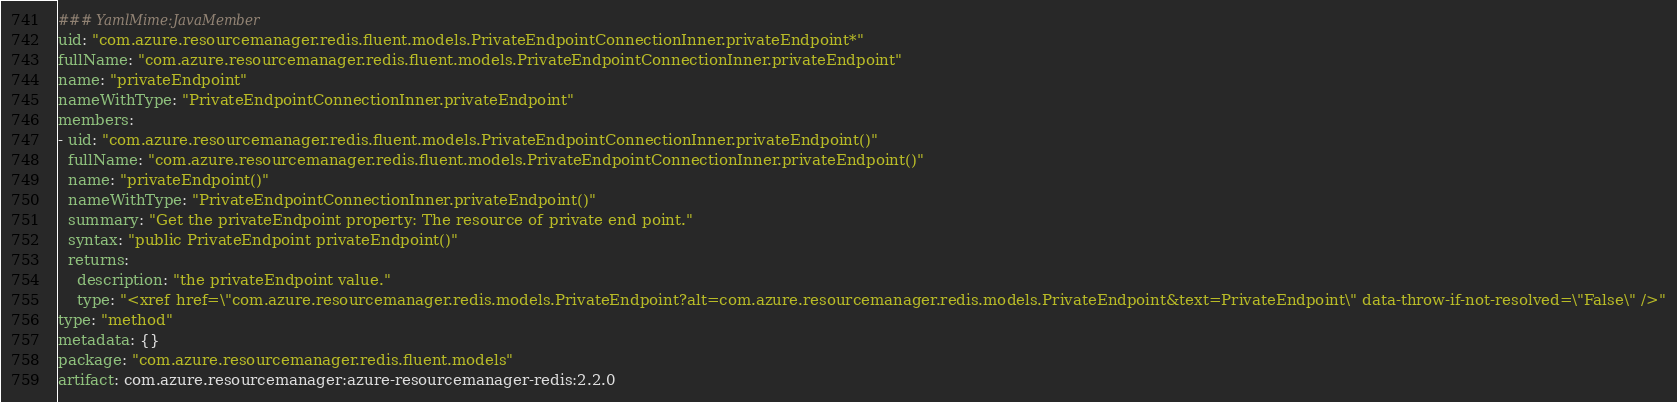Convert code to text. <code><loc_0><loc_0><loc_500><loc_500><_YAML_>### YamlMime:JavaMember
uid: "com.azure.resourcemanager.redis.fluent.models.PrivateEndpointConnectionInner.privateEndpoint*"
fullName: "com.azure.resourcemanager.redis.fluent.models.PrivateEndpointConnectionInner.privateEndpoint"
name: "privateEndpoint"
nameWithType: "PrivateEndpointConnectionInner.privateEndpoint"
members:
- uid: "com.azure.resourcemanager.redis.fluent.models.PrivateEndpointConnectionInner.privateEndpoint()"
  fullName: "com.azure.resourcemanager.redis.fluent.models.PrivateEndpointConnectionInner.privateEndpoint()"
  name: "privateEndpoint()"
  nameWithType: "PrivateEndpointConnectionInner.privateEndpoint()"
  summary: "Get the privateEndpoint property: The resource of private end point."
  syntax: "public PrivateEndpoint privateEndpoint()"
  returns:
    description: "the privateEndpoint value."
    type: "<xref href=\"com.azure.resourcemanager.redis.models.PrivateEndpoint?alt=com.azure.resourcemanager.redis.models.PrivateEndpoint&text=PrivateEndpoint\" data-throw-if-not-resolved=\"False\" />"
type: "method"
metadata: {}
package: "com.azure.resourcemanager.redis.fluent.models"
artifact: com.azure.resourcemanager:azure-resourcemanager-redis:2.2.0
</code> 